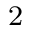<formula> <loc_0><loc_0><loc_500><loc_500>\text  subscript { 2 }</formula> 